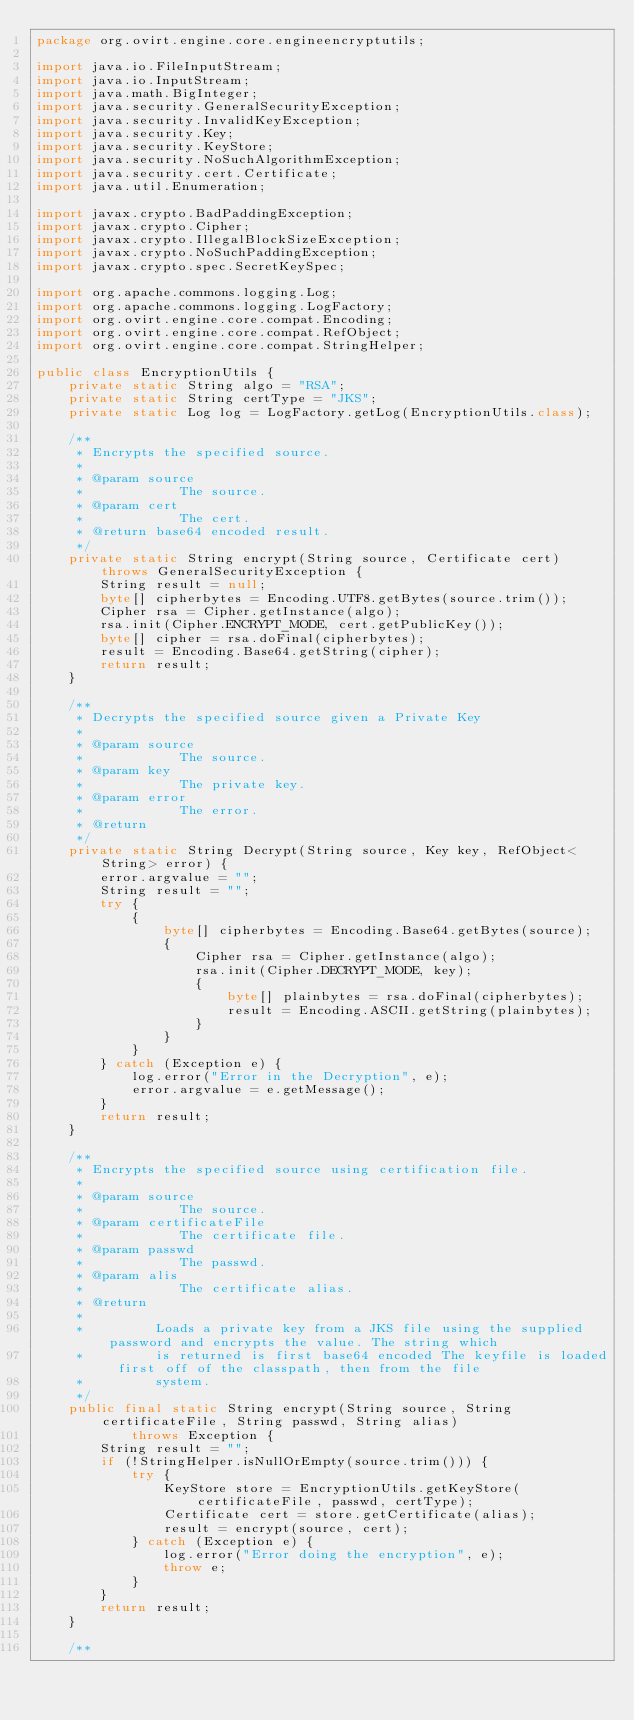<code> <loc_0><loc_0><loc_500><loc_500><_Java_>package org.ovirt.engine.core.engineencryptutils;

import java.io.FileInputStream;
import java.io.InputStream;
import java.math.BigInteger;
import java.security.GeneralSecurityException;
import java.security.InvalidKeyException;
import java.security.Key;
import java.security.KeyStore;
import java.security.NoSuchAlgorithmException;
import java.security.cert.Certificate;
import java.util.Enumeration;

import javax.crypto.BadPaddingException;
import javax.crypto.Cipher;
import javax.crypto.IllegalBlockSizeException;
import javax.crypto.NoSuchPaddingException;
import javax.crypto.spec.SecretKeySpec;

import org.apache.commons.logging.Log;
import org.apache.commons.logging.LogFactory;
import org.ovirt.engine.core.compat.Encoding;
import org.ovirt.engine.core.compat.RefObject;
import org.ovirt.engine.core.compat.StringHelper;

public class EncryptionUtils {
    private static String algo = "RSA";
    private static String certType = "JKS";
    private static Log log = LogFactory.getLog(EncryptionUtils.class);

    /**
     * Encrypts the specified source.
     *
     * @param source
     *            The source.
     * @param cert
     *            The cert.
     * @return base64 encoded result.
     */
    private static String encrypt(String source, Certificate cert) throws GeneralSecurityException {
        String result = null;
        byte[] cipherbytes = Encoding.UTF8.getBytes(source.trim());
        Cipher rsa = Cipher.getInstance(algo);
        rsa.init(Cipher.ENCRYPT_MODE, cert.getPublicKey());
        byte[] cipher = rsa.doFinal(cipherbytes);
        result = Encoding.Base64.getString(cipher);
        return result;
    }

    /**
     * Decrypts the specified source given a Private Key
     *
     * @param source
     *            The source.
     * @param key
     *            The private key.
     * @param error
     *            The error.
     * @return
     */
    private static String Decrypt(String source, Key key, RefObject<String> error) {
        error.argvalue = "";
        String result = "";
        try {
            {
                byte[] cipherbytes = Encoding.Base64.getBytes(source);
                {
                    Cipher rsa = Cipher.getInstance(algo);
                    rsa.init(Cipher.DECRYPT_MODE, key);
                    {
                        byte[] plainbytes = rsa.doFinal(cipherbytes);
                        result = Encoding.ASCII.getString(plainbytes);
                    }
                }
            }
        } catch (Exception e) {
            log.error("Error in the Decryption", e);
            error.argvalue = e.getMessage();
        }
        return result;
    }

    /**
     * Encrypts the specified source using certification file.
     *
     * @param source
     *            The source.
     * @param certificateFile
     *            The certificate file.
     * @param passwd
     *            The passwd.
     * @param alis
     *            The certificate alias.
     * @return
     *
     *         Loads a private key from a JKS file using the supplied password and encrypts the value. The string which
     *         is returned is first base64 encoded The keyfile is loaded first off of the classpath, then from the file
     *         system.
     */
    public final static String encrypt(String source, String certificateFile, String passwd, String alias)
            throws Exception {
        String result = "";
        if (!StringHelper.isNullOrEmpty(source.trim())) {
            try {
                KeyStore store = EncryptionUtils.getKeyStore(certificateFile, passwd, certType);
                Certificate cert = store.getCertificate(alias);
                result = encrypt(source, cert);
            } catch (Exception e) {
                log.error("Error doing the encryption", e);
                throw e;
            }
        }
        return result;
    }

    /**</code> 